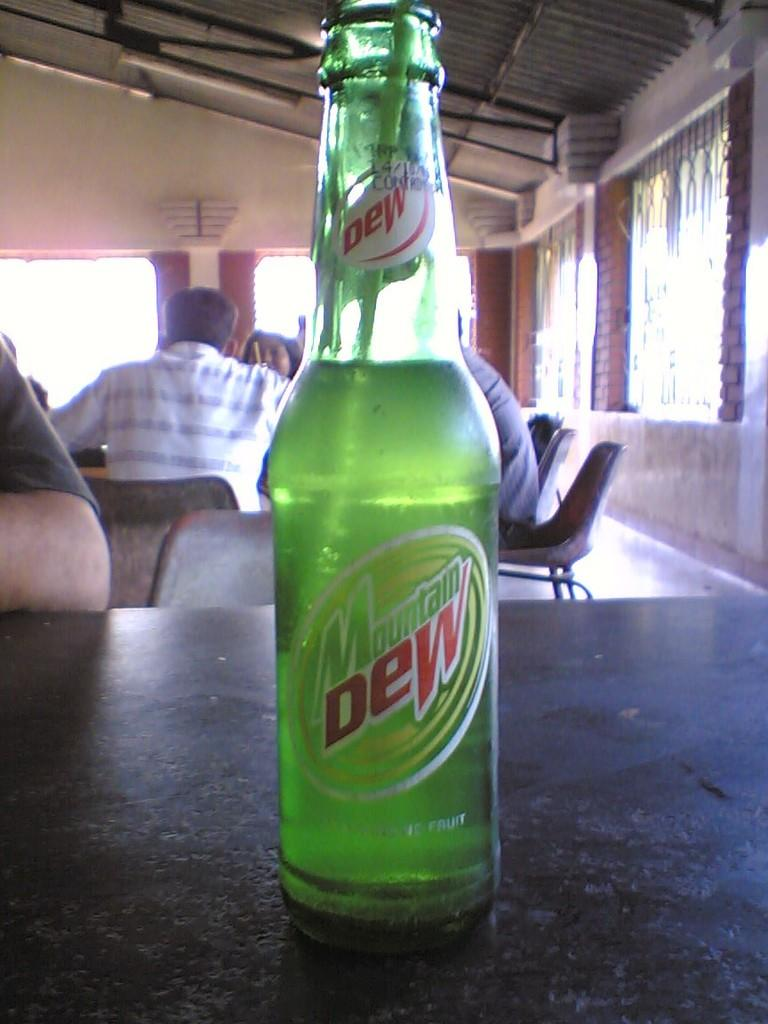How many people are in the image? There is a group of people in the image, but the exact number cannot be determined from the provided facts. What is on the table in the image? There is a bottle on a table in the image. What is the source of light in the image? There is a light at the top of the image. What can be seen at the right side of the image? There is a window at the right side of the image. What type of engine can be seen in the image? There is no engine present in the image. Is there any grass visible in the image? The provided facts do not mention any grass in the image. How many cattle are present in the image? The provided facts do not mention any cattle in the image. 